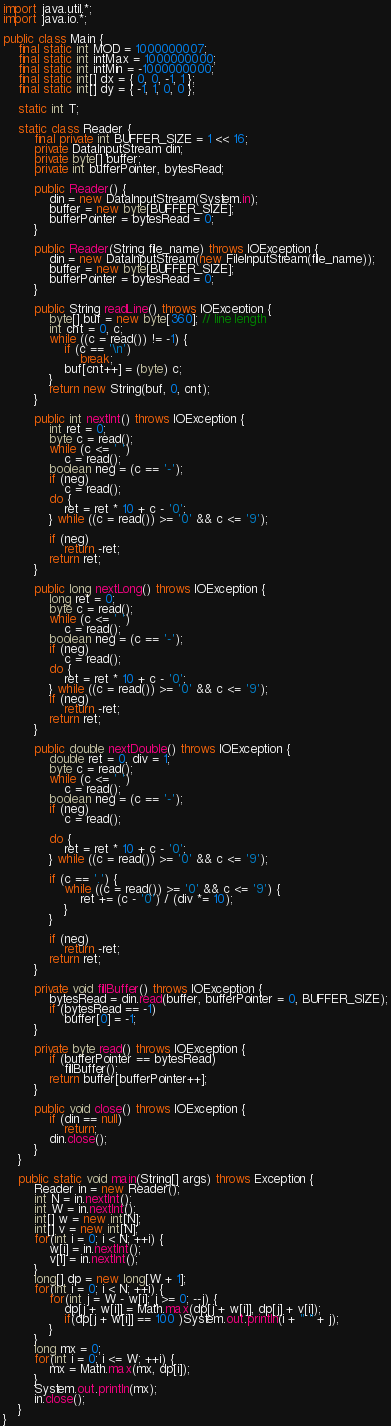<code> <loc_0><loc_0><loc_500><loc_500><_Java_>import java.util.*;
import java.io.*;

public class Main {
	final static int MOD = 1000000007;
	final static int intMax = 1000000000;
	final static int intMin = -1000000000;
	final static int[] dx = { 0, 0, -1, 1 };
	final static int[] dy = { -1, 1, 0, 0 };

	static int T;

	static class Reader {
		final private int BUFFER_SIZE = 1 << 16;
		private DataInputStream din;
		private byte[] buffer;
		private int bufferPointer, bytesRead;

		public Reader() {
			din = new DataInputStream(System.in);
			buffer = new byte[BUFFER_SIZE];
			bufferPointer = bytesRead = 0;
		}

		public Reader(String file_name) throws IOException {
			din = new DataInputStream(new FileInputStream(file_name));
			buffer = new byte[BUFFER_SIZE];
			bufferPointer = bytesRead = 0;
		}

		public String readLine() throws IOException {
			byte[] buf = new byte[360]; // line length
			int cnt = 0, c;
			while ((c = read()) != -1) {
				if (c == '\n')
					break;
				buf[cnt++] = (byte) c;
			}
			return new String(buf, 0, cnt);
		}

		public int nextInt() throws IOException {
			int ret = 0;
			byte c = read();
			while (c <= ' ')
				c = read();
			boolean neg = (c == '-');
			if (neg)
				c = read();
			do {
				ret = ret * 10 + c - '0';
			} while ((c = read()) >= '0' && c <= '9');

			if (neg)
				return -ret;
			return ret;
		}

		public long nextLong() throws IOException {
			long ret = 0;
			byte c = read();
			while (c <= ' ')
				c = read();
			boolean neg = (c == '-');
			if (neg)
				c = read();
			do {
				ret = ret * 10 + c - '0';
			} while ((c = read()) >= '0' && c <= '9');
			if (neg)
				return -ret;
			return ret;
		}

		public double nextDouble() throws IOException {
			double ret = 0, div = 1;
			byte c = read();
			while (c <= ' ')
				c = read();
			boolean neg = (c == '-');
			if (neg)
				c = read();

			do {
				ret = ret * 10 + c - '0';
			} while ((c = read()) >= '0' && c <= '9');

			if (c == '.') {
				while ((c = read()) >= '0' && c <= '9') {
					ret += (c - '0') / (div *= 10);
				}
			}

			if (neg)
				return -ret;
			return ret;
		}

		private void fillBuffer() throws IOException {
			bytesRead = din.read(buffer, bufferPointer = 0, BUFFER_SIZE);
			if (bytesRead == -1)
				buffer[0] = -1;
		}

		private byte read() throws IOException {
			if (bufferPointer == bytesRead)
				fillBuffer();
			return buffer[bufferPointer++];
		}

		public void close() throws IOException {
			if (din == null)
				return;
			din.close();
		}
	}
	
	public static void main(String[] args) throws Exception {
		Reader in = new Reader();
		int N = in.nextInt();
		int W = in.nextInt();
		int[] w = new int[N];
		int[] v = new int[N];
		for(int i = 0; i < N; ++i) {
			w[i] = in.nextInt();
			v[i] = in.nextInt();
		}
		long[] dp = new long[W + 1];
		for(int i = 0; i < N; ++i) {
			for(int j = W - w[i]; j >= 0; --j) {
				dp[j + w[i]] = Math.max(dp[j + w[i]], dp[j] + v[i]);
				if(dp[j + w[i]] == 100 )System.out.println(i + " " + j);
			}
		}
		long mx = 0;
		for(int i = 0; i <= W; ++i) {
			mx = Math.max(mx, dp[i]);
		}
		System.out.println(mx);
		in.close();
	}
}</code> 